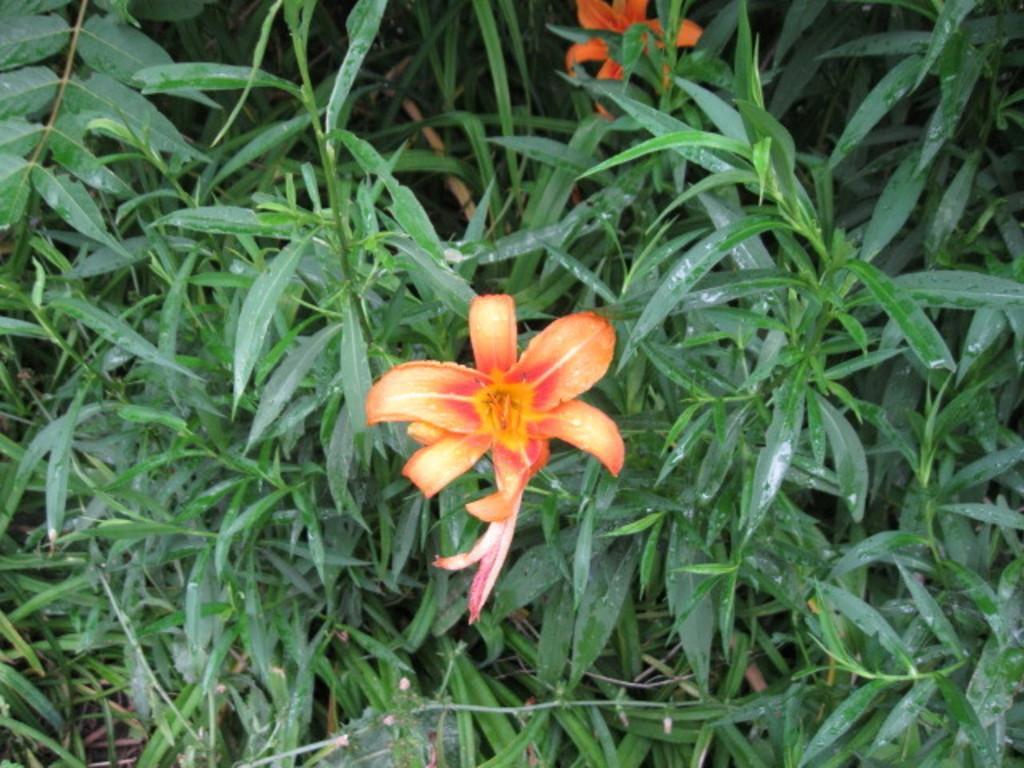Can you describe this image briefly? In this picture we can see some plants, there are two flowers and leaves in the front. 